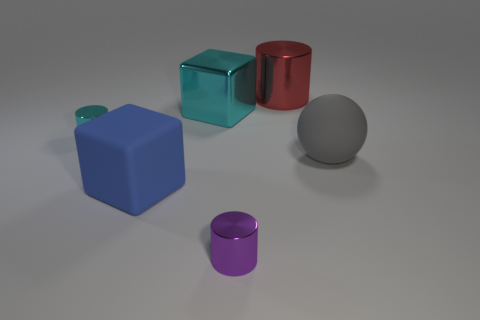Subtract all tiny cylinders. How many cylinders are left? 1 Subtract all spheres. How many objects are left? 5 Subtract 1 balls. How many balls are left? 0 Subtract all cyan spheres. Subtract all green cubes. How many spheres are left? 1 Subtract all purple balls. How many red cylinders are left? 1 Subtract all purple things. Subtract all metal things. How many objects are left? 1 Add 5 blue matte blocks. How many blue matte blocks are left? 6 Add 3 yellow balls. How many yellow balls exist? 3 Add 3 cubes. How many objects exist? 9 Subtract all red cylinders. How many cylinders are left? 2 